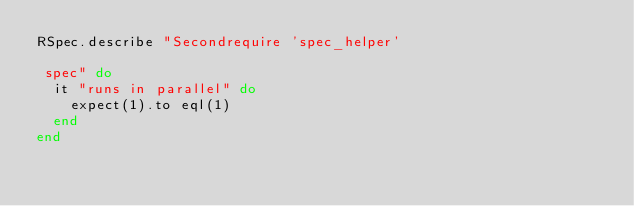Convert code to text. <code><loc_0><loc_0><loc_500><loc_500><_Ruby_>RSpec.describe "Secondrequire 'spec_helper'

 spec" do
  it "runs in parallel" do
    expect(1).to eql(1)
  end
end</code> 